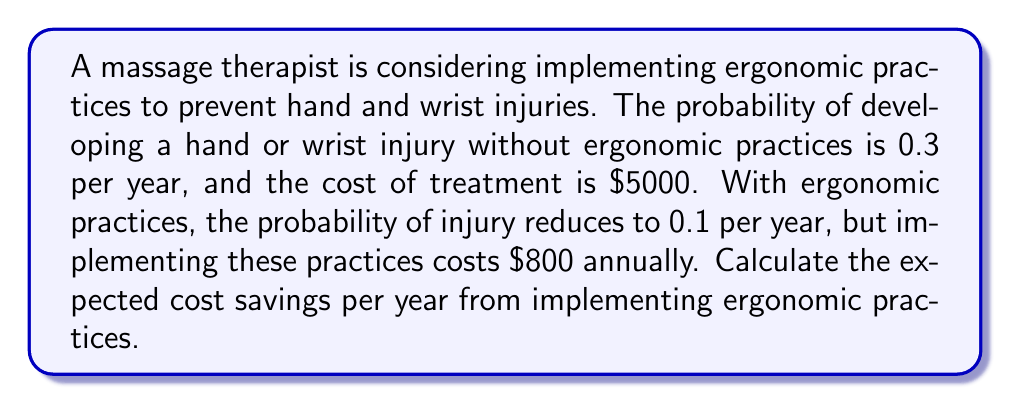Could you help me with this problem? Let's approach this step-by-step:

1) First, calculate the expected cost without ergonomic practices:
   $$E(\text{cost without practices}) = P(\text{injury}) \times \text{cost of treatment}$$
   $$E(\text{cost without practices}) = 0.3 \times \$5000 = \$1500$$

2) Now, calculate the expected cost with ergonomic practices:
   $$E(\text{cost with practices}) = P(\text{injury}) \times \text{cost of treatment} + \text{cost of practices}$$
   $$E(\text{cost with practices}) = 0.1 \times \$5000 + \$800 = \$500 + \$800 = \$1300$$

3) The expected cost savings is the difference between these two:
   $$E(\text{savings}) = E(\text{cost without practices}) - E(\text{cost with practices})$$
   $$E(\text{savings}) = \$1500 - \$1300 = \$200$$

Therefore, the expected cost savings per year from implementing ergonomic practices is $200.
Answer: $200 